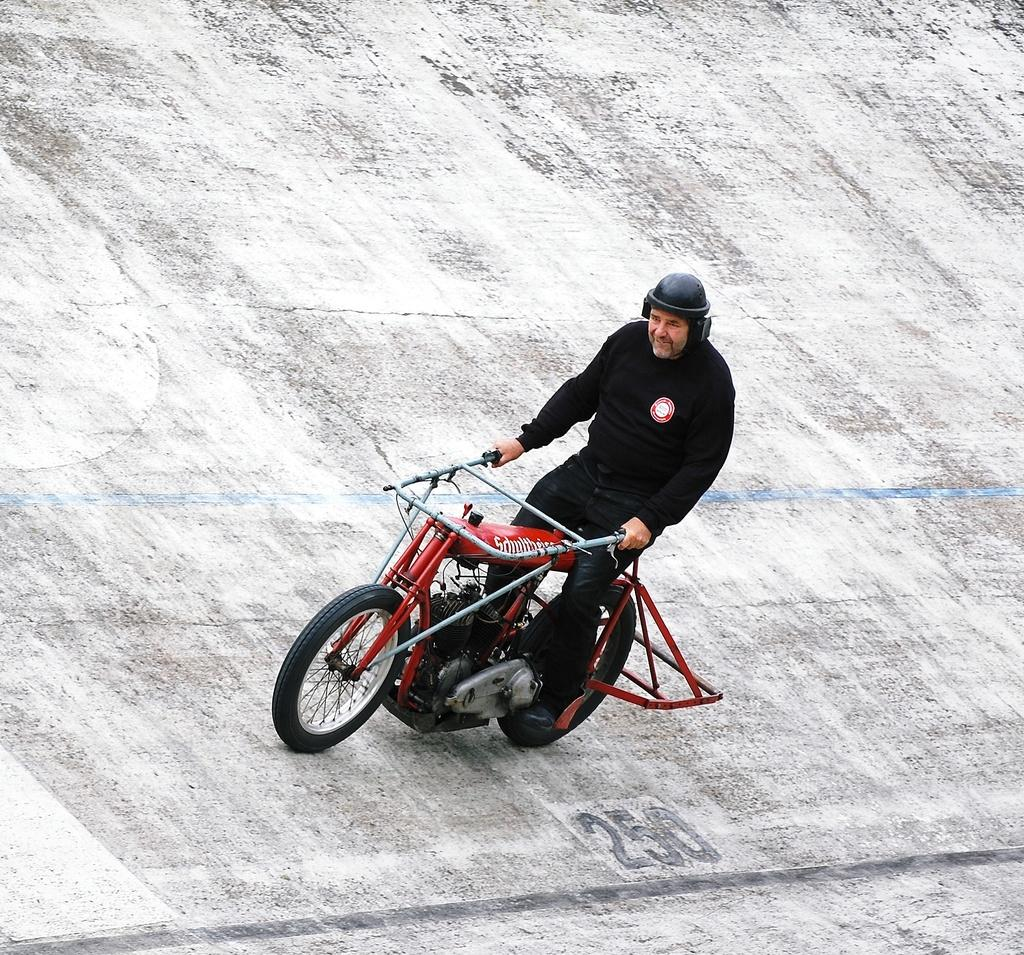What is the man in the image doing? The man is riding a vehicle in the image. What is the vehicle on in the image? The vehicle is on a slanted wall in the image. What is the man wearing on his upper body? The man is wearing a black t-shirt in the image. What is the man wearing on his lower body? The man is wearing black jeans in the image. What is the man wearing on his head? The man is wearing a black helmet in the image. What color is the bike in the image? The bike is red in color in the image. Can you see any farm animals in the image? There are no farm animals present in the image. Is the man swimming in the image? The man is not swimming in the image; he is riding a vehicle on a slanted wall. 